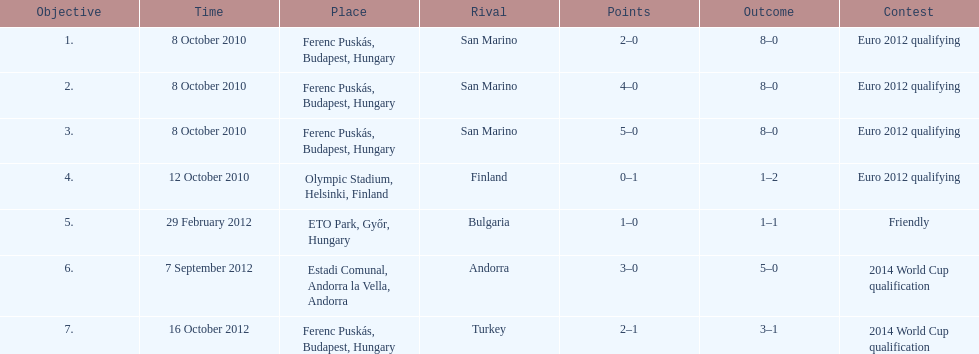How many consecutive games were goals were against san marino? 3. 